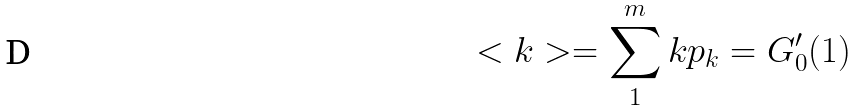Convert formula to latex. <formula><loc_0><loc_0><loc_500><loc_500>< k > = \sum _ { 1 } ^ { m } k p _ { k } = G _ { 0 } ^ { \prime } ( 1 )</formula> 